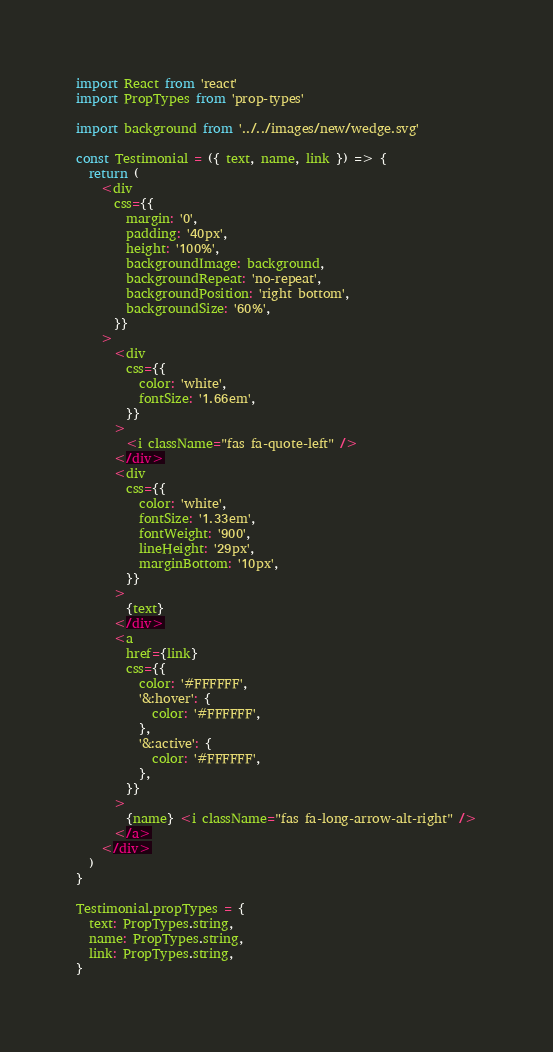<code> <loc_0><loc_0><loc_500><loc_500><_JavaScript_>import React from 'react'
import PropTypes from 'prop-types'

import background from '../../images/new/wedge.svg'

const Testimonial = ({ text, name, link }) => {
  return (
    <div
      css={{
        margin: '0',
        padding: '40px',
        height: '100%',
        backgroundImage: background,
        backgroundRepeat: 'no-repeat',
        backgroundPosition: 'right bottom',
        backgroundSize: '60%',
      }}
    >
      <div
        css={{
          color: 'white',
          fontSize: '1.66em',
        }}
      >
        <i className="fas fa-quote-left" />
      </div>
      <div
        css={{
          color: 'white',
          fontSize: '1.33em',
          fontWeight: '900',
          lineHeight: '29px',
          marginBottom: '10px',
        }}
      >
        {text}
      </div>
      <a
        href={link}
        css={{
          color: '#FFFFFF',
          '&:hover': {
            color: '#FFFFFF',
          },
          '&:active': {
            color: '#FFFFFF',
          },
        }}
      >
        {name} <i className="fas fa-long-arrow-alt-right" />
      </a>
    </div>
  )
}

Testimonial.propTypes = {
  text: PropTypes.string,
  name: PropTypes.string,
  link: PropTypes.string,
}
</code> 